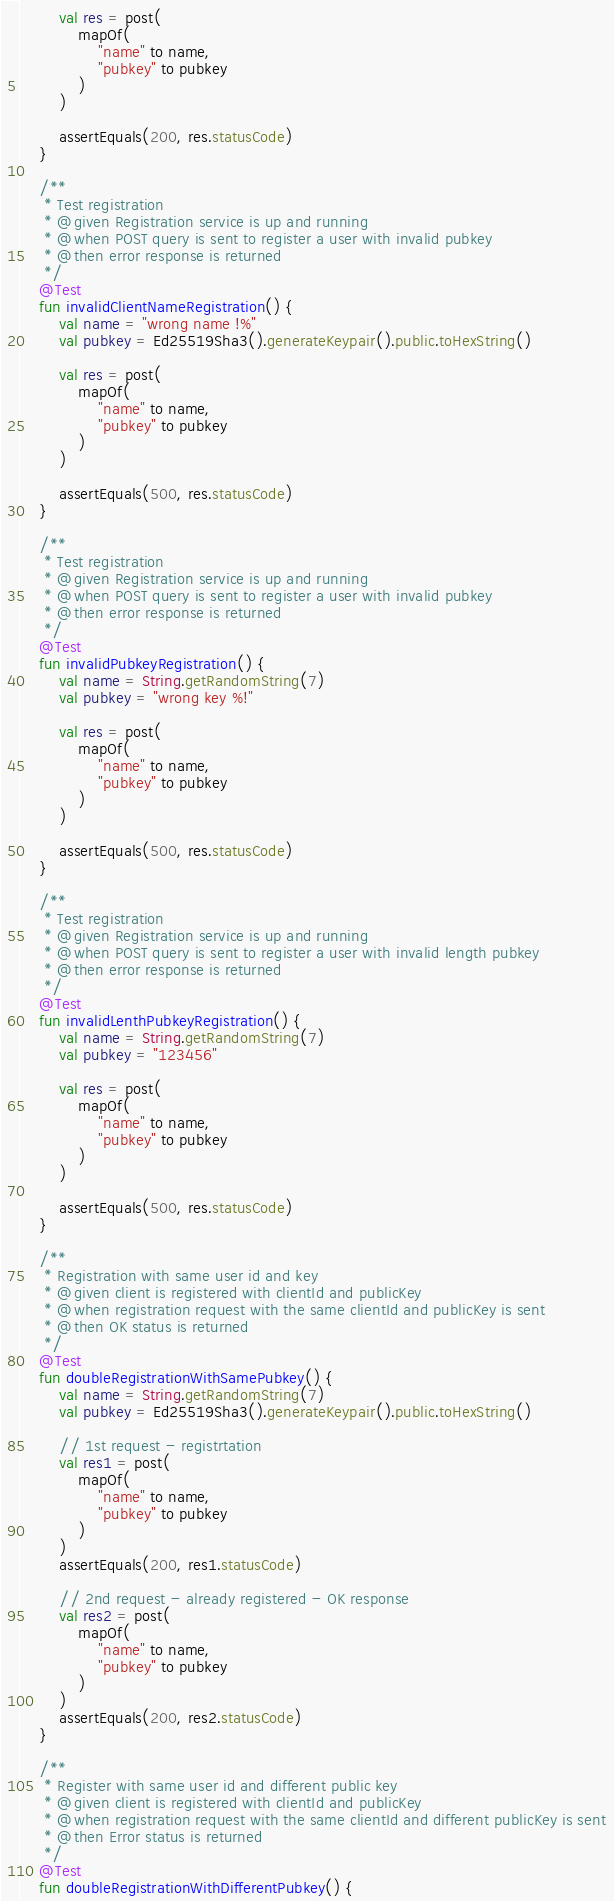<code> <loc_0><loc_0><loc_500><loc_500><_Kotlin_>
        val res = post(
            mapOf(
                "name" to name,
                "pubkey" to pubkey
            )
        )

        assertEquals(200, res.statusCode)
    }

    /**
     * Test registration
     * @given Registration service is up and running
     * @when POST query is sent to register a user with invalid pubkey
     * @then error response is returned
     */
    @Test
    fun invalidClientNameRegistration() {
        val name = "wrong name !%"
        val pubkey = Ed25519Sha3().generateKeypair().public.toHexString()

        val res = post(
            mapOf(
                "name" to name,
                "pubkey" to pubkey
            )
        )

        assertEquals(500, res.statusCode)
    }

    /**
     * Test registration
     * @given Registration service is up and running
     * @when POST query is sent to register a user with invalid pubkey
     * @then error response is returned
     */
    @Test
    fun invalidPubkeyRegistration() {
        val name = String.getRandomString(7)
        val pubkey = "wrong key %!"

        val res = post(
            mapOf(
                "name" to name,
                "pubkey" to pubkey
            )
        )

        assertEquals(500, res.statusCode)
    }

    /**
     * Test registration
     * @given Registration service is up and running
     * @when POST query is sent to register a user with invalid length pubkey
     * @then error response is returned
     */
    @Test
    fun invalidLenthPubkeyRegistration() {
        val name = String.getRandomString(7)
        val pubkey = "123456"

        val res = post(
            mapOf(
                "name" to name,
                "pubkey" to pubkey
            )
        )

        assertEquals(500, res.statusCode)
    }

    /**
     * Registration with same user id and key
     * @given client is registered with clientId and publicKey
     * @when registration request with the same clientId and publicKey is sent
     * @then OK status is returned
     */
    @Test
    fun doubleRegistrationWithSamePubkey() {
        val name = String.getRandomString(7)
        val pubkey = Ed25519Sha3().generateKeypair().public.toHexString()

        // 1st request - registrtation
        val res1 = post(
            mapOf(
                "name" to name,
                "pubkey" to pubkey
            )
        )
        assertEquals(200, res1.statusCode)

        // 2nd request - already registered - OK response
        val res2 = post(
            mapOf(
                "name" to name,
                "pubkey" to pubkey
            )
        )
        assertEquals(200, res2.statusCode)
    }

    /**
     * Register with same user id and different public key
     * @given client is registered with clientId and publicKey
     * @when registration request with the same clientId and different publicKey is sent
     * @then Error status is returned
     */
    @Test
    fun doubleRegistrationWithDifferentPubkey() {</code> 